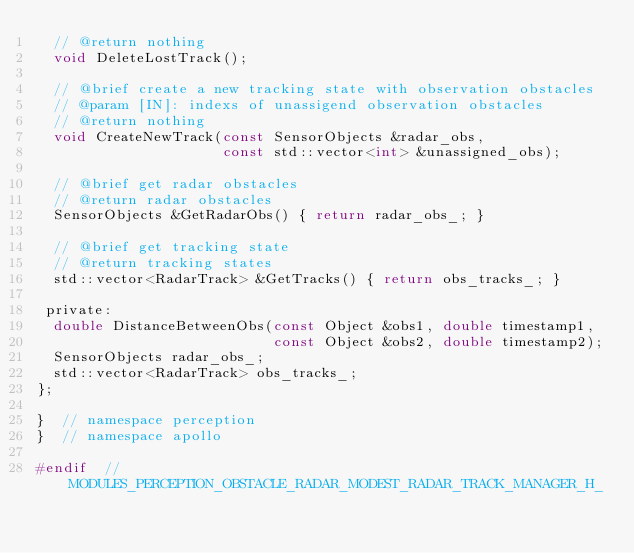<code> <loc_0><loc_0><loc_500><loc_500><_C_>  // @return nothing
  void DeleteLostTrack();

  // @brief create a new tracking state with observation obstacles
  // @param [IN]: indexs of unassigend observation obstacles
  // @return nothing
  void CreateNewTrack(const SensorObjects &radar_obs,
                      const std::vector<int> &unassigned_obs);

  // @brief get radar obstacles
  // @return radar obstacles
  SensorObjects &GetRadarObs() { return radar_obs_; }

  // @brief get tracking state
  // @return tracking states
  std::vector<RadarTrack> &GetTracks() { return obs_tracks_; }

 private:
  double DistanceBetweenObs(const Object &obs1, double timestamp1,
                            const Object &obs2, double timestamp2);
  SensorObjects radar_obs_;
  std::vector<RadarTrack> obs_tracks_;
};

}  // namespace perception
}  // namespace apollo

#endif  // MODULES_PERCEPTION_OBSTACLE_RADAR_MODEST_RADAR_TRACK_MANAGER_H_
</code> 